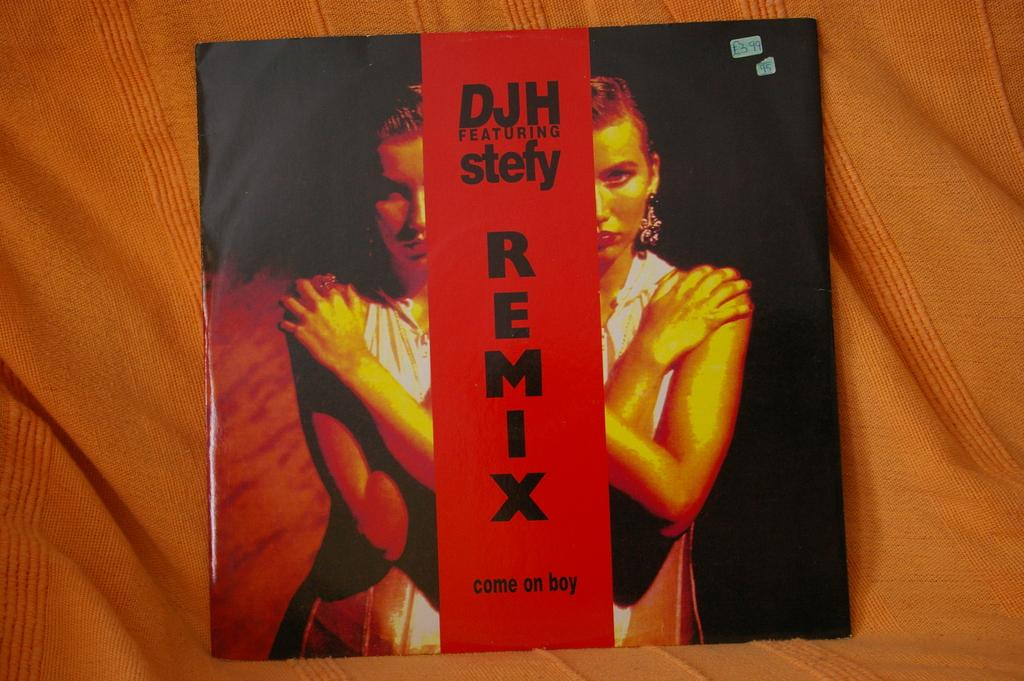Provide a one-sentence caption for the provided image. An album cover with a remix from DJH featuring Stefy. 